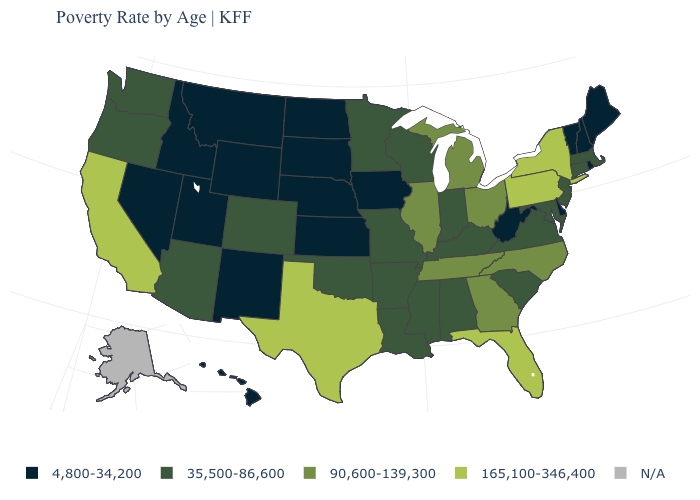Name the states that have a value in the range 35,500-86,600?
Give a very brief answer. Alabama, Arizona, Arkansas, Colorado, Connecticut, Indiana, Kentucky, Louisiana, Maryland, Massachusetts, Minnesota, Mississippi, Missouri, New Jersey, Oklahoma, Oregon, South Carolina, Virginia, Washington, Wisconsin. What is the value of Idaho?
Write a very short answer. 4,800-34,200. What is the value of Connecticut?
Quick response, please. 35,500-86,600. What is the value of California?
Write a very short answer. 165,100-346,400. Name the states that have a value in the range 165,100-346,400?
Concise answer only. California, Florida, New York, Pennsylvania, Texas. Name the states that have a value in the range 165,100-346,400?
Concise answer only. California, Florida, New York, Pennsylvania, Texas. What is the value of Georgia?
Write a very short answer. 90,600-139,300. What is the highest value in the MidWest ?
Give a very brief answer. 90,600-139,300. Does Nevada have the lowest value in the West?
Quick response, please. Yes. What is the highest value in the West ?
Short answer required. 165,100-346,400. Among the states that border Maryland , does Pennsylvania have the highest value?
Concise answer only. Yes. What is the highest value in the MidWest ?
Answer briefly. 90,600-139,300. Which states hav the highest value in the West?
Short answer required. California. Name the states that have a value in the range 4,800-34,200?
Keep it brief. Delaware, Hawaii, Idaho, Iowa, Kansas, Maine, Montana, Nebraska, Nevada, New Hampshire, New Mexico, North Dakota, Rhode Island, South Dakota, Utah, Vermont, West Virginia, Wyoming. 